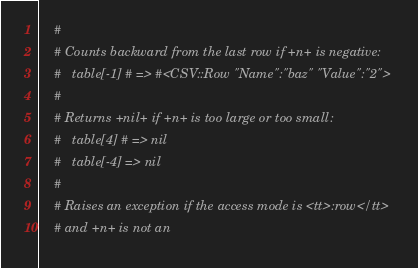<code> <loc_0><loc_0><loc_500><loc_500><_Ruby_>    #
    # Counts backward from the last row if +n+ is negative:
    #   table[-1] # => #<CSV::Row "Name":"baz" "Value":"2">
    #
    # Returns +nil+ if +n+ is too large or too small:
    #   table[4] # => nil
    #   table[-4] => nil
    #
    # Raises an exception if the access mode is <tt>:row</tt>
    # and +n+ is not an</code> 